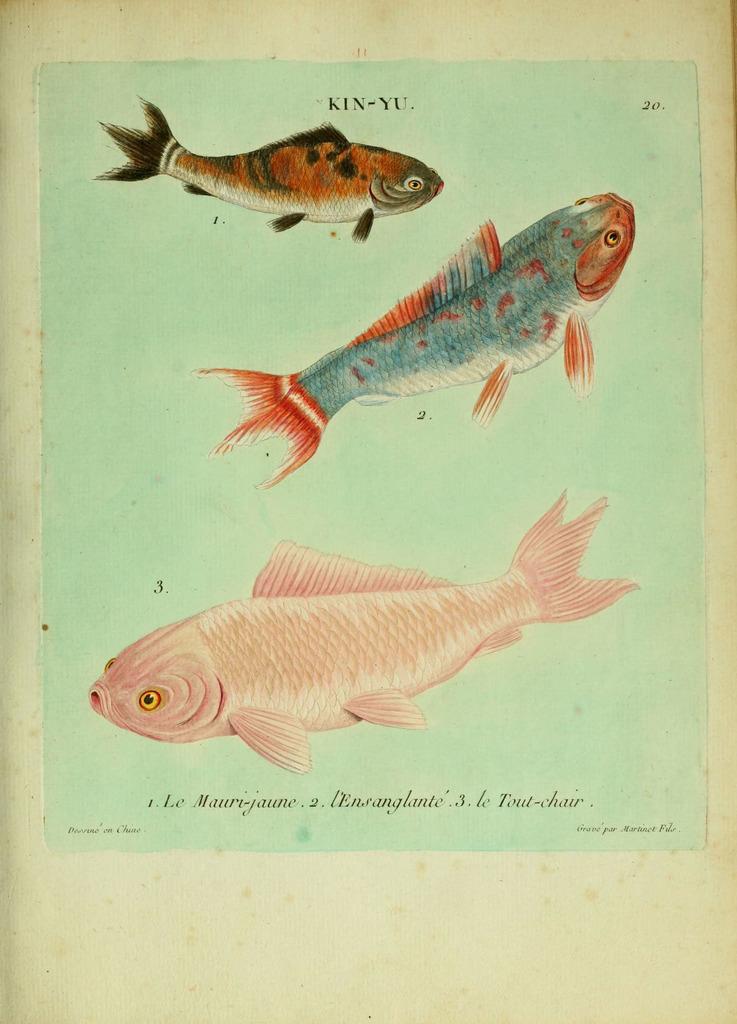Could you give a brief overview of what you see in this image? In the foreground of this poster, there are diagrams of fishes and text is on the top and the bottom. 